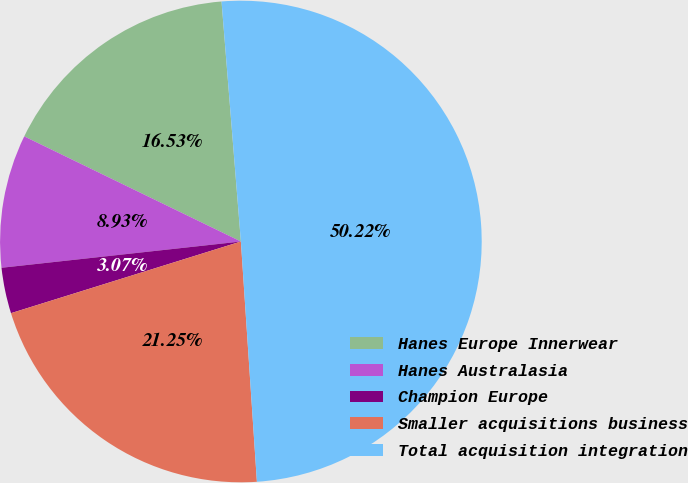Convert chart. <chart><loc_0><loc_0><loc_500><loc_500><pie_chart><fcel>Hanes Europe Innerwear<fcel>Hanes Australasia<fcel>Champion Europe<fcel>Smaller acquisitions business<fcel>Total acquisition integration<nl><fcel>16.53%<fcel>8.93%<fcel>3.07%<fcel>21.25%<fcel>50.22%<nl></chart> 